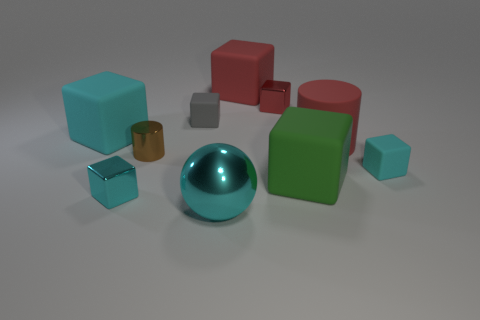Are there fewer small metallic things than large yellow matte blocks?
Your answer should be very brief. No. There is a green thing that is the same size as the red rubber cube; what is its material?
Give a very brief answer. Rubber. How many things are either tiny gray rubber balls or gray cubes?
Your answer should be compact. 1. What number of tiny cubes are right of the large matte cylinder and left of the red metallic cube?
Give a very brief answer. 0. Is the number of red metallic things on the right side of the green thing less than the number of brown blocks?
Your answer should be very brief. No. What is the shape of the cyan metallic thing that is the same size as the red matte cylinder?
Provide a succinct answer. Sphere. What number of other things are the same color as the matte cylinder?
Your answer should be very brief. 2. Is the green matte cube the same size as the shiny ball?
Give a very brief answer. Yes. How many things are either big green cubes or big objects on the right side of the cyan sphere?
Give a very brief answer. 3. Are there fewer metallic things that are in front of the large cyan shiny object than metal blocks that are right of the tiny cylinder?
Ensure brevity in your answer.  Yes. 